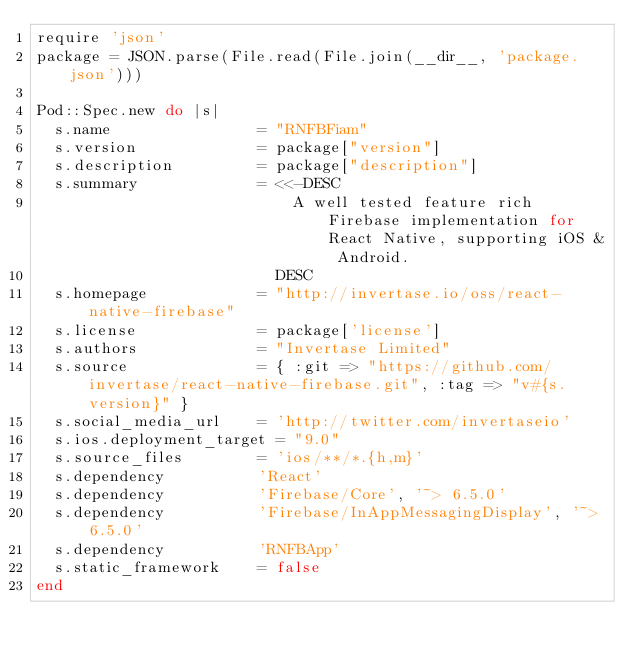<code> <loc_0><loc_0><loc_500><loc_500><_Ruby_>require 'json'
package = JSON.parse(File.read(File.join(__dir__, 'package.json')))

Pod::Spec.new do |s|
  s.name                = "RNFBFiam"
  s.version             = package["version"]
  s.description         = package["description"]
  s.summary             = <<-DESC
                            A well tested feature rich Firebase implementation for React Native, supporting iOS & Android.
                          DESC
  s.homepage            = "http://invertase.io/oss/react-native-firebase"
  s.license             = package['license']
  s.authors             = "Invertase Limited"
  s.source              = { :git => "https://github.com/invertase/react-native-firebase.git", :tag => "v#{s.version}" }
  s.social_media_url    = 'http://twitter.com/invertaseio'
  s.ios.deployment_target = "9.0"
  s.source_files        = 'ios/**/*.{h,m}'
  s.dependency          'React'
  s.dependency          'Firebase/Core', '~> 6.5.0'
  s.dependency          'Firebase/InAppMessagingDisplay', '~> 6.5.0'
  s.dependency          'RNFBApp'
  s.static_framework    = false
end
</code> 